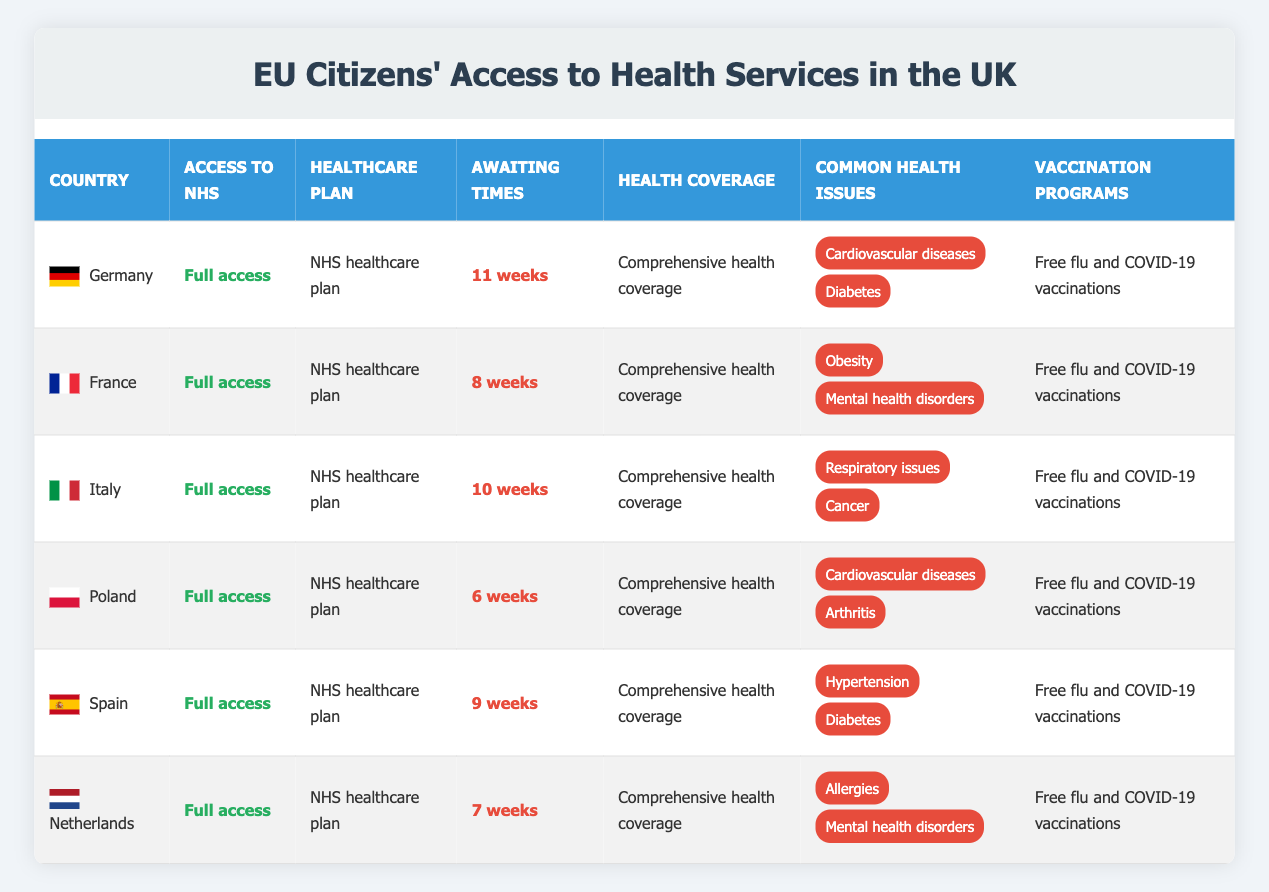What is the waiting time for healthcare services in Poland? The table shows that the awaiting time for healthcare services in Poland is listed as 6 weeks.
Answer: 6 weeks Which countries have full access to the NHS? The table indicates that all listed countries (Germany, France, Italy, Poland, Spain, Netherlands) have "Full access" to the NHS.
Answer: All listed countries What is the average waiting time for healthcare services across all countries? The waiting times listed are 11, 8, 10, 6, 9, and 7 weeks. Summing them gives 11 + 8 + 10 + 6 + 9 + 7 = 51 weeks. There are 6 countries, so the average waiting time is 51 / 6 = 8.5 weeks.
Answer: 8.5 weeks Does France have a vaccination program for flu and COVID-19? According to the table, France offers free flu and COVID-19 vaccinations, which confirms that they have a vaccination program.
Answer: Yes Which country has the longest awaiting time for NHS services, and what is it? The longest awaiting time in the table is 11 weeks, which is associated with Germany.
Answer: Germany, 11 weeks What are the common health issues reported for Italy? The table lists the common health issues for Italy as "Respiratory issues" and "Cancer."
Answer: Respiratory issues and Cancer Is there a country among the listed ones that has an awaiting time of less than 7 weeks? Upon reviewing the table, Poland has the shortest waiting time listed at 6 weeks, which is indeed less than 7 weeks.
Answer: Yes, Poland What is the relationship between access to NHS services and healthcare plans across the countries shown? The table states that all countries have full access to NHS services and are on the NHS healthcare plan, indicating a direct relationship where full access equals enrollment in the NHS plan.
Answer: All have full access and NHS plans How many common health issues are reported for Spain? The table mentions two common health issues for Spain: "Hypertension" and "Diabetes," indicating a total of two common health issues.
Answer: 2 common health issues If we remove the country with the highest awaiting time from consideration, what would be the average waiting time for the remaining countries? Removing Germany (11 weeks), we have the waiting times 8, 10, 6, 9, and 7 weeks left. Their sum is 8 + 10 + 6 + 9 + 7 = 40 weeks. There are 5 countries left, so the new average is 40 / 5 = 8 weeks.
Answer: 8 weeks 